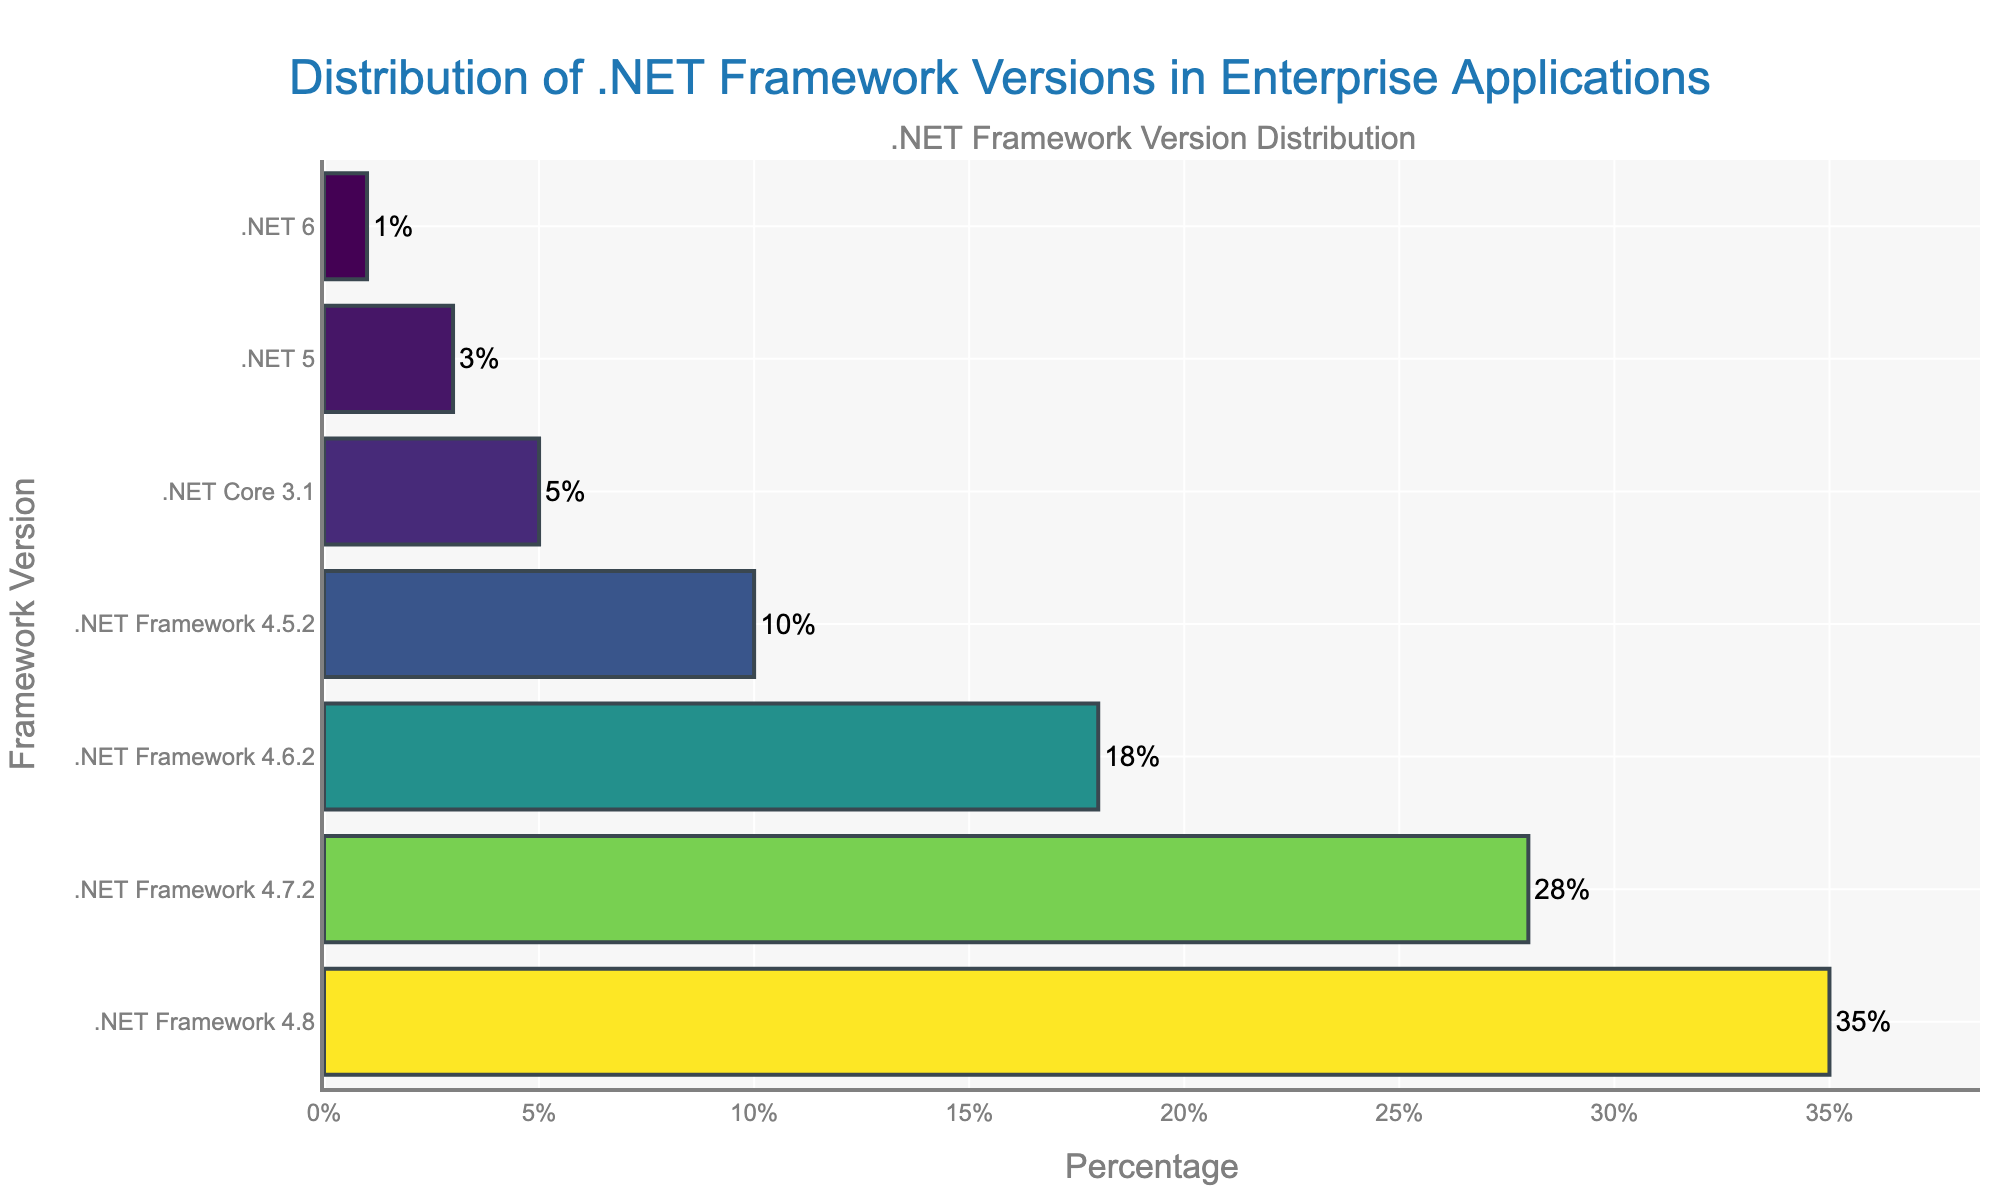What is the title of the plot? The title of the plot is located at the top center of the figure and reads "Distribution of .NET Framework Versions in Enterprise Applications".
Answer: Distribution of .NET Framework Versions in Enterprise Applications Which .NET Framework version has the highest percentage? The bar with the longest length represents the .NET Framework version with the highest percentage, which is .NET Framework 4.8 at 35%.
Answer: .NET Framework 4.8 How many different versions of .NET Framework are represented in the figure? Count the number of unique bar labels along the y-axis. There are 7 versions shown.
Answer: 7 Which .NET versions have a percentage less than 10%? Identify the bars in the plot with percentages below 10%. These are .NET Core 3.1 (5%), .NET 5 (3%), and .NET 6 (1%).
Answer: .NET Core 3.1, .NET 5, .NET 6 What is the combined percentage of .NET Core 3.1 and .NET 5? Add the percentages of .NET Core 3.1 (5%) and .NET 5 (3%) together: 5% + 3% = 8%.
Answer: 8% Which version has a percentage exactly 1%? Find the bar whose label reads 1%. The version is .NET 6.
Answer: .NET 6 How does the percentage of .NET Framework 4.7.2 compare to .NET Framework 4.5.2? Locate the bars for .NET Framework 4.7.2 (28%) and .NET Framework 4.5.2 (10%) and compare their lengths. The percentage for .NET Framework 4.7.2 is greater than that of .NET Framework 4.5.2 by 18%.
Answer: .NET Framework 4.7.2 is 18% greater What is the average percentage of the .NET Framework versions (excluding .NET Core and .NET versions)? Sum the percentages of .NET Framework 4.8 (35%), .NET Framework 4.7.2 (28%), .NET Framework 4.6.2 (18%), and .NET Framework 4.5.2 (10%) and divide by 4: (35 + 28 + 18 + 10) / 4 = 22.75%.
Answer: 22.75% Rank the .NET Framework versions by their percentage in descending order. Arrange the percentages from highest to lowest: .NET Framework 4.8 (35%), .NET Framework 4.7.2 (28%), .NET Framework 4.6.2 (18%), .NET Framework 4.5.2 (10%), .NET Core 3.1 (5%), .NET 5 (3%), .NET 6 (1%).
Answer: .NET Framework 4.8, .NET Framework 4.7.2, .NET Framework 4.6.2, .NET Framework 4.5.2, .NET Core 3.1, .NET 5, .NET 6 